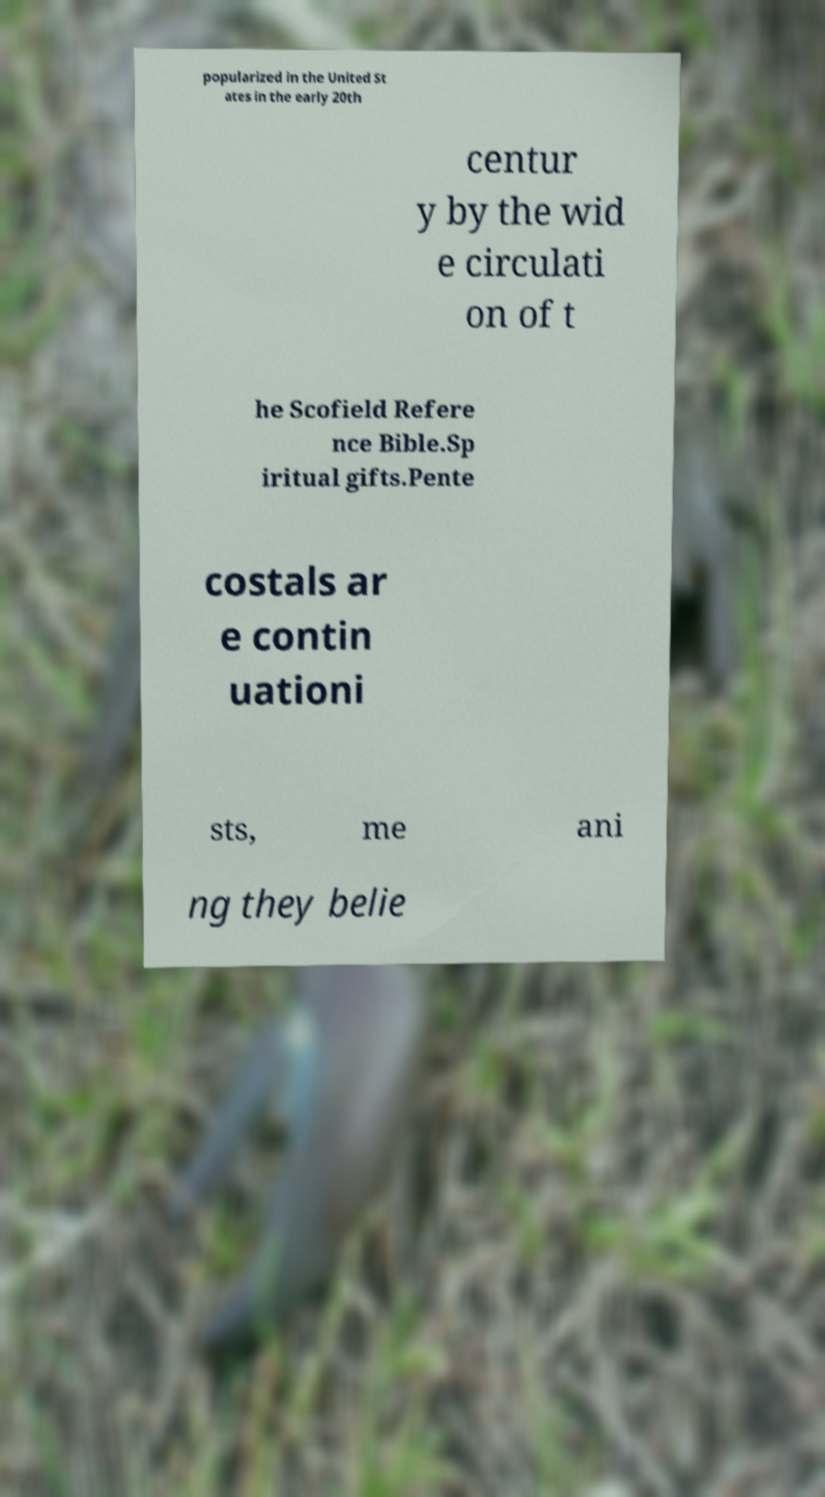Please read and relay the text visible in this image. What does it say? popularized in the United St ates in the early 20th centur y by the wid e circulati on of t he Scofield Refere nce Bible.Sp iritual gifts.Pente costals ar e contin uationi sts, me ani ng they belie 